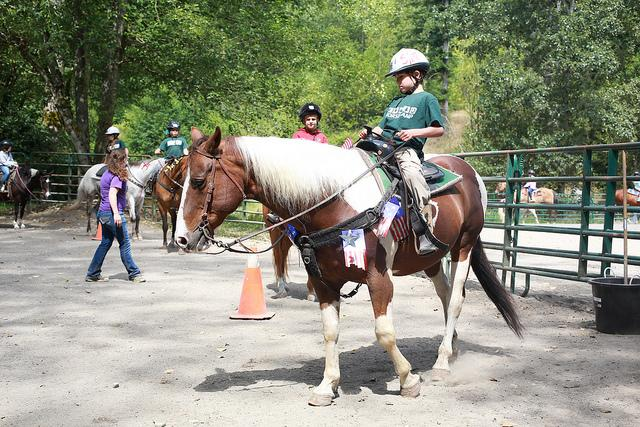Which person works at this facility?

Choices:
A) red top
B) back kid
C) front kid
D) purple shirt purple shirt 